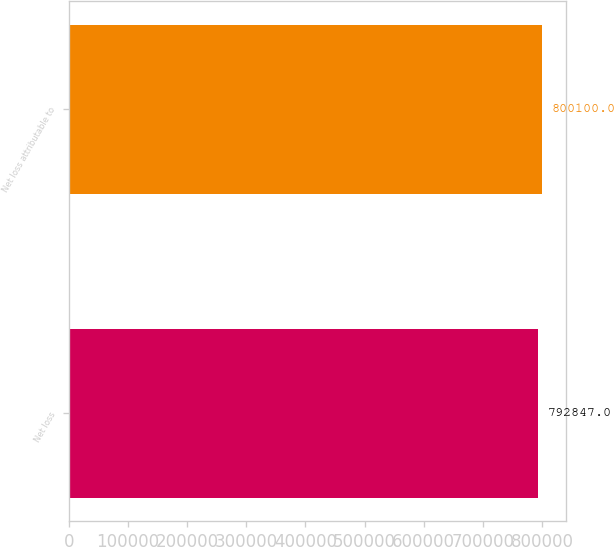<chart> <loc_0><loc_0><loc_500><loc_500><bar_chart><fcel>Net loss<fcel>Net loss attributable to<nl><fcel>792847<fcel>800100<nl></chart> 